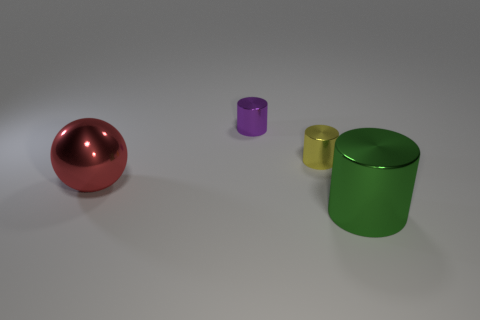Add 2 tiny shiny things. How many objects exist? 6 Subtract all cylinders. How many objects are left? 1 Subtract 0 blue blocks. How many objects are left? 4 Subtract all big red metal objects. Subtract all green things. How many objects are left? 2 Add 4 yellow cylinders. How many yellow cylinders are left? 5 Add 1 small red rubber cylinders. How many small red rubber cylinders exist? 1 